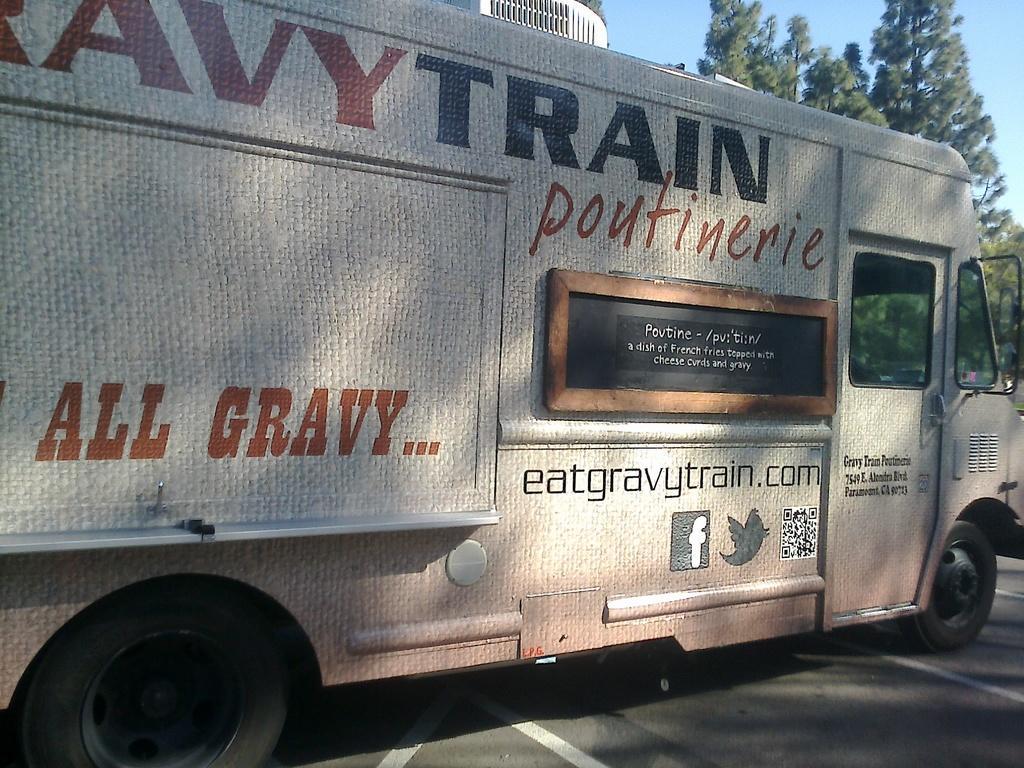Please provide a concise description of this image. In this image, we can see a vehicle is placed on the road. Here we can see few white lines. Background there are few trees and sky we can see. 